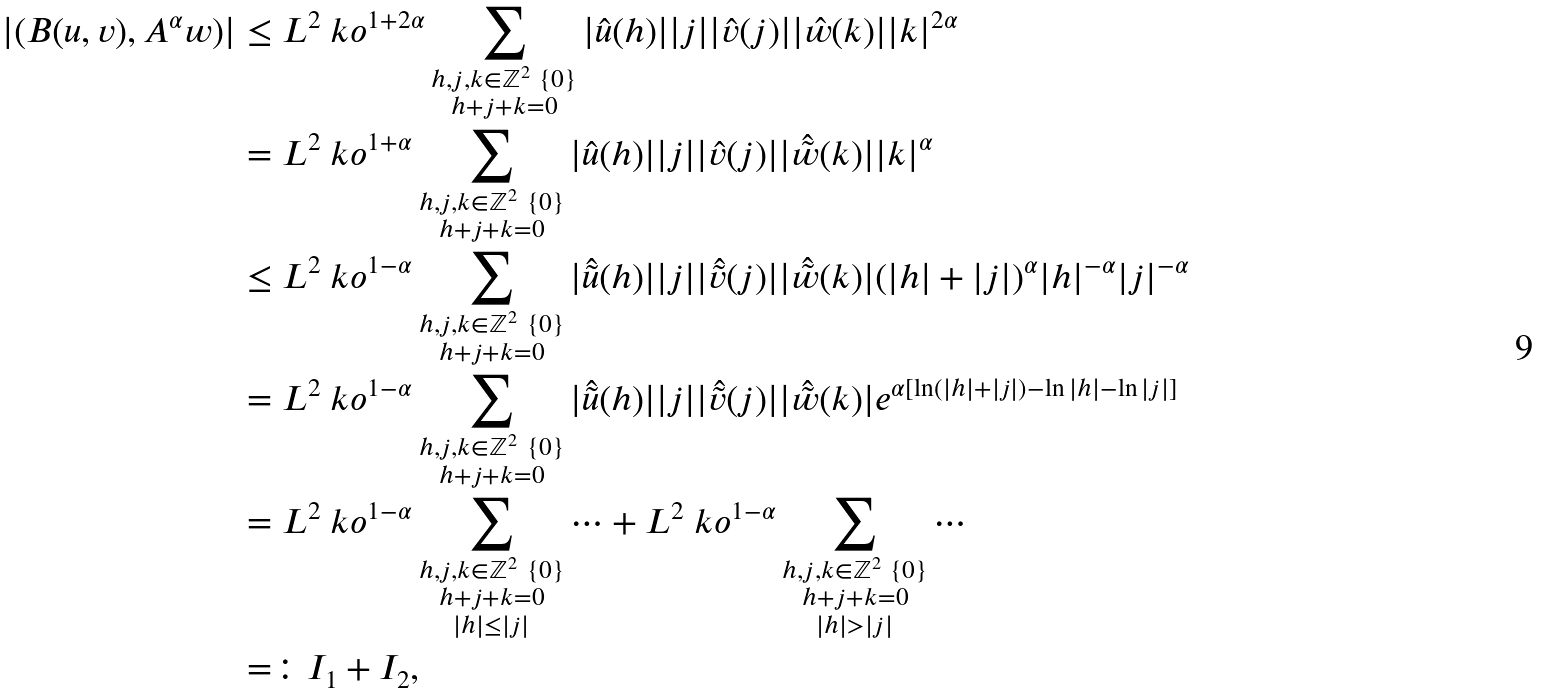Convert formula to latex. <formula><loc_0><loc_0><loc_500><loc_500>| ( B ( u , v ) , A ^ { \alpha } w ) | & \leq L ^ { 2 } \ k o ^ { 1 + 2 \alpha } \sum _ { \substack { h , j , k \in \mathbb { Z } ^ { 2 } \ \{ 0 \} \\ h + j + k = 0 } } | \hat { u } ( h ) | | j | | \hat { v } ( j ) | | \hat { w } ( k ) | | k | ^ { 2 \alpha } \\ & = L ^ { 2 } \ k o ^ { 1 + \alpha } \sum _ { \substack { h , j , k \in \mathbb { Z } ^ { 2 } \ \{ 0 \} \\ h + j + k = 0 } } | \hat { u } ( h ) | | j | | \hat { v } ( j ) | | \hat { \tilde { w } } ( k ) | | k | ^ { \alpha } \\ & \leq L ^ { 2 } \ k o ^ { 1 - \alpha } \sum _ { \substack { h , j , k \in \mathbb { Z } ^ { 2 } \ \{ 0 \} \\ h + j + k = 0 } } | \hat { \tilde { u } } ( h ) | | j | | \hat { \tilde { v } } ( j ) | | \hat { \tilde { w } } ( k ) | ( | h | + | j | ) ^ { \alpha } | h | ^ { - \alpha } | j | ^ { - \alpha } \\ & = L ^ { 2 } \ k o ^ { 1 - \alpha } \sum _ { \substack { h , j , k \in \mathbb { Z } ^ { 2 } \ \{ 0 \} \\ h + j + k = 0 } } | \hat { \tilde { u } } ( h ) | | j | | \hat { \tilde { v } } ( j ) | | \hat { \tilde { w } } ( k ) | e ^ { \alpha [ \ln ( | h | + | j | ) - \ln | h | - \ln | j | ] } \\ & = L ^ { 2 } \ k o ^ { 1 - \alpha } \sum _ { \substack { h , j , k \in \mathbb { Z } ^ { 2 } \ \{ 0 \} \\ h + j + k = 0 \\ | h | \leq | j | } } \cdots + L ^ { 2 } \ k o ^ { 1 - \alpha } \sum _ { \substack { h , j , k \in \mathbb { Z } ^ { 2 } \ \{ 0 \} \\ h + j + k = 0 \\ | h | > | j | } } \cdots \\ & = \colon I _ { 1 } + I _ { 2 } ,</formula> 